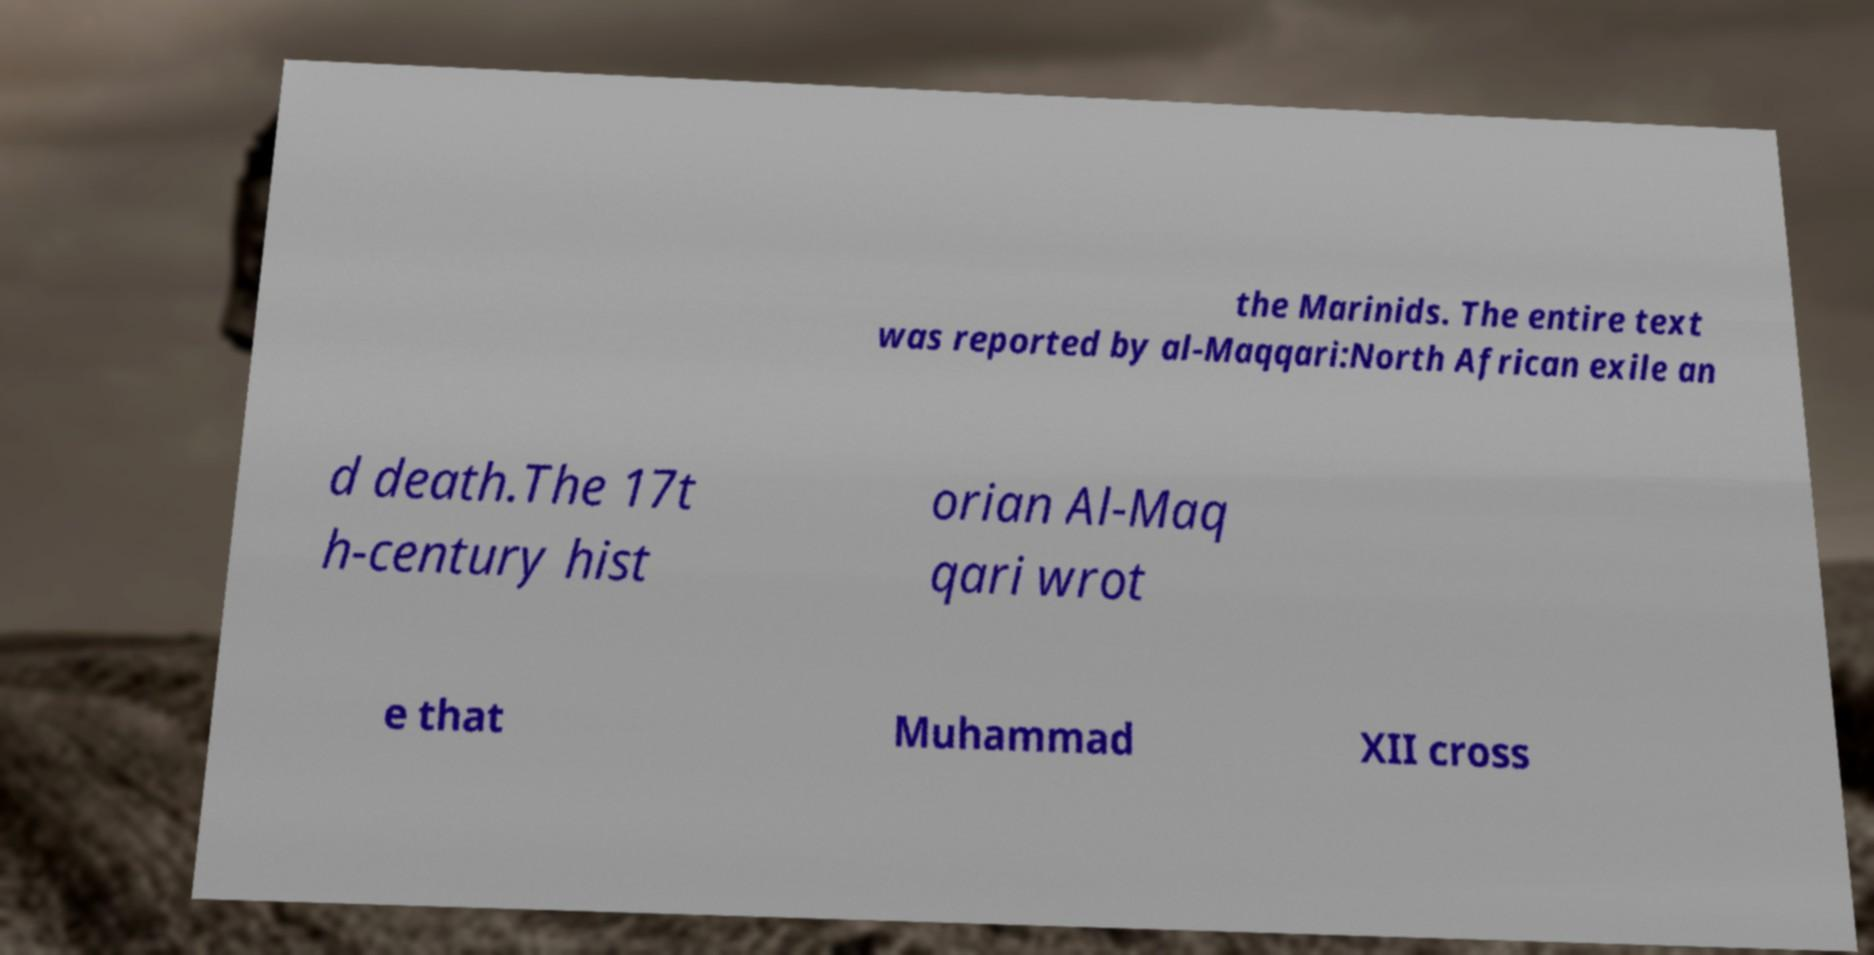Can you read and provide the text displayed in the image?This photo seems to have some interesting text. Can you extract and type it out for me? the Marinids. The entire text was reported by al-Maqqari:North African exile an d death.The 17t h-century hist orian Al-Maq qari wrot e that Muhammad XII cross 